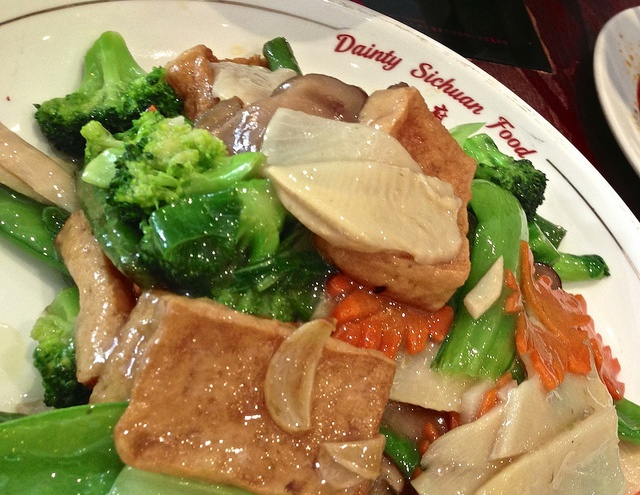Describe the objects in this image and their specific colors. I can see dining table in brown, tan, black, and beige tones, broccoli in beige, black, darkgreen, and olive tones, broccoli in beige, olive, and tan tones, broccoli in beige, olive, lightgreen, and darkgreen tones, and broccoli in beige, black, olive, lightgreen, and darkgreen tones in this image. 